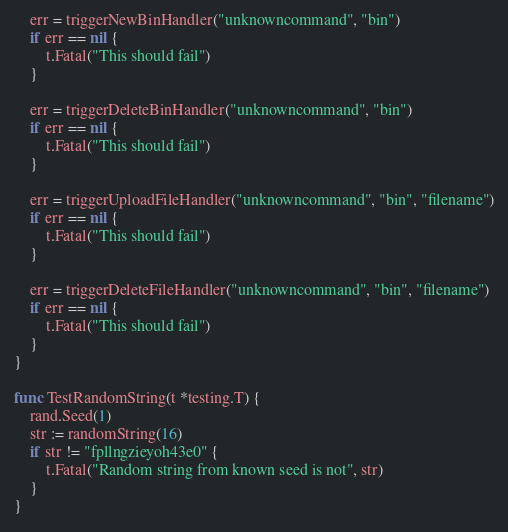Convert code to text. <code><loc_0><loc_0><loc_500><loc_500><_Go_>	err = triggerNewBinHandler("unknowncommand", "bin")
	if err == nil {
		t.Fatal("This should fail")
	}

	err = triggerDeleteBinHandler("unknowncommand", "bin")
	if err == nil {
		t.Fatal("This should fail")
	}

	err = triggerUploadFileHandler("unknowncommand", "bin", "filename")
	if err == nil {
		t.Fatal("This should fail")
	}

	err = triggerDeleteFileHandler("unknowncommand", "bin", "filename")
	if err == nil {
		t.Fatal("This should fail")
	}
}

func TestRandomString(t *testing.T) {
	rand.Seed(1)
	str := randomString(16)
	if str != "fpllngzieyoh43e0" {
		t.Fatal("Random string from known seed is not", str)
	}
}
</code> 